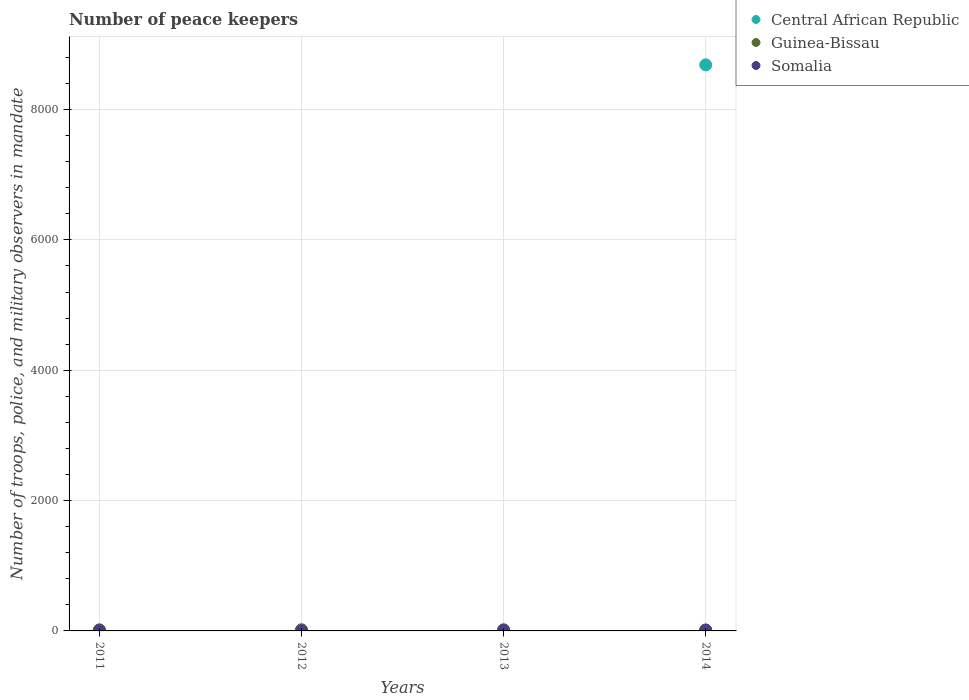Is the number of dotlines equal to the number of legend labels?
Your answer should be compact. Yes. Across all years, what is the minimum number of peace keepers in in Somalia?
Provide a succinct answer. 3. In which year was the number of peace keepers in in Somalia maximum?
Your response must be concise. 2014. In which year was the number of peace keepers in in Central African Republic minimum?
Your answer should be very brief. 2011. What is the total number of peace keepers in in Central African Republic in the graph?
Offer a very short reply. 8697. What is the difference between the number of peace keepers in in Guinea-Bissau in 2013 and that in 2014?
Offer a terse response. 4. What is the average number of peace keepers in in Guinea-Bissau per year?
Your answer should be compact. 16.75. In how many years, is the number of peace keepers in in Somalia greater than 5600?
Your response must be concise. 0. What is the ratio of the number of peace keepers in in Central African Republic in 2011 to that in 2012?
Your answer should be very brief. 1. Is the number of peace keepers in in Central African Republic in 2012 less than that in 2014?
Offer a very short reply. Yes. Is the difference between the number of peace keepers in in Somalia in 2011 and 2013 greater than the difference between the number of peace keepers in in Guinea-Bissau in 2011 and 2013?
Provide a succinct answer. No. What is the difference between the highest and the lowest number of peace keepers in in Central African Republic?
Provide a succinct answer. 8681. In how many years, is the number of peace keepers in in Guinea-Bissau greater than the average number of peace keepers in in Guinea-Bissau taken over all years?
Make the answer very short. 3. Is it the case that in every year, the sum of the number of peace keepers in in Guinea-Bissau and number of peace keepers in in Somalia  is greater than the number of peace keepers in in Central African Republic?
Provide a succinct answer. No. Is the number of peace keepers in in Guinea-Bissau strictly less than the number of peace keepers in in Central African Republic over the years?
Offer a very short reply. No. How many years are there in the graph?
Ensure brevity in your answer.  4. What is the difference between two consecutive major ticks on the Y-axis?
Your answer should be compact. 2000. Does the graph contain grids?
Provide a succinct answer. Yes. How many legend labels are there?
Make the answer very short. 3. How are the legend labels stacked?
Your response must be concise. Vertical. What is the title of the graph?
Offer a terse response. Number of peace keepers. What is the label or title of the Y-axis?
Offer a very short reply. Number of troops, police, and military observers in mandate. What is the Number of troops, police, and military observers in mandate in Central African Republic in 2011?
Offer a terse response. 4. What is the Number of troops, police, and military observers in mandate of Somalia in 2011?
Offer a very short reply. 6. What is the Number of troops, police, and military observers in mandate of Central African Republic in 2012?
Your answer should be very brief. 4. What is the Number of troops, police, and military observers in mandate in Guinea-Bissau in 2012?
Your answer should be very brief. 18. What is the Number of troops, police, and military observers in mandate of Somalia in 2012?
Ensure brevity in your answer.  3. What is the Number of troops, police, and military observers in mandate of Guinea-Bissau in 2013?
Give a very brief answer. 18. What is the Number of troops, police, and military observers in mandate of Central African Republic in 2014?
Offer a very short reply. 8685. What is the Number of troops, police, and military observers in mandate of Guinea-Bissau in 2014?
Your answer should be very brief. 14. What is the Number of troops, police, and military observers in mandate in Somalia in 2014?
Ensure brevity in your answer.  12. Across all years, what is the maximum Number of troops, police, and military observers in mandate in Central African Republic?
Offer a terse response. 8685. Across all years, what is the maximum Number of troops, police, and military observers in mandate of Guinea-Bissau?
Offer a very short reply. 18. Across all years, what is the maximum Number of troops, police, and military observers in mandate in Somalia?
Your answer should be compact. 12. Across all years, what is the minimum Number of troops, police, and military observers in mandate in Central African Republic?
Make the answer very short. 4. Across all years, what is the minimum Number of troops, police, and military observers in mandate in Somalia?
Provide a short and direct response. 3. What is the total Number of troops, police, and military observers in mandate in Central African Republic in the graph?
Provide a succinct answer. 8697. What is the total Number of troops, police, and military observers in mandate in Guinea-Bissau in the graph?
Make the answer very short. 67. What is the total Number of troops, police, and military observers in mandate of Somalia in the graph?
Give a very brief answer. 30. What is the difference between the Number of troops, police, and military observers in mandate of Central African Republic in 2011 and that in 2013?
Your answer should be very brief. 0. What is the difference between the Number of troops, police, and military observers in mandate in Central African Republic in 2011 and that in 2014?
Provide a succinct answer. -8681. What is the difference between the Number of troops, police, and military observers in mandate of Somalia in 2011 and that in 2014?
Your answer should be very brief. -6. What is the difference between the Number of troops, police, and military observers in mandate of Central African Republic in 2012 and that in 2013?
Ensure brevity in your answer.  0. What is the difference between the Number of troops, police, and military observers in mandate of Guinea-Bissau in 2012 and that in 2013?
Give a very brief answer. 0. What is the difference between the Number of troops, police, and military observers in mandate of Central African Republic in 2012 and that in 2014?
Offer a terse response. -8681. What is the difference between the Number of troops, police, and military observers in mandate in Guinea-Bissau in 2012 and that in 2014?
Your response must be concise. 4. What is the difference between the Number of troops, police, and military observers in mandate of Somalia in 2012 and that in 2014?
Offer a very short reply. -9. What is the difference between the Number of troops, police, and military observers in mandate of Central African Republic in 2013 and that in 2014?
Your answer should be compact. -8681. What is the difference between the Number of troops, police, and military observers in mandate in Guinea-Bissau in 2011 and the Number of troops, police, and military observers in mandate in Somalia in 2012?
Ensure brevity in your answer.  14. What is the difference between the Number of troops, police, and military observers in mandate in Central African Republic in 2011 and the Number of troops, police, and military observers in mandate in Guinea-Bissau in 2014?
Your response must be concise. -10. What is the difference between the Number of troops, police, and military observers in mandate of Guinea-Bissau in 2011 and the Number of troops, police, and military observers in mandate of Somalia in 2014?
Keep it short and to the point. 5. What is the difference between the Number of troops, police, and military observers in mandate in Central African Republic in 2012 and the Number of troops, police, and military observers in mandate in Guinea-Bissau in 2013?
Your answer should be compact. -14. What is the difference between the Number of troops, police, and military observers in mandate of Central African Republic in 2012 and the Number of troops, police, and military observers in mandate of Somalia in 2013?
Ensure brevity in your answer.  -5. What is the difference between the Number of troops, police, and military observers in mandate of Guinea-Bissau in 2012 and the Number of troops, police, and military observers in mandate of Somalia in 2013?
Provide a succinct answer. 9. What is the difference between the Number of troops, police, and military observers in mandate of Central African Republic in 2012 and the Number of troops, police, and military observers in mandate of Guinea-Bissau in 2014?
Ensure brevity in your answer.  -10. What is the difference between the Number of troops, police, and military observers in mandate of Central African Republic in 2012 and the Number of troops, police, and military observers in mandate of Somalia in 2014?
Your response must be concise. -8. What is the difference between the Number of troops, police, and military observers in mandate of Guinea-Bissau in 2012 and the Number of troops, police, and military observers in mandate of Somalia in 2014?
Provide a succinct answer. 6. What is the difference between the Number of troops, police, and military observers in mandate of Guinea-Bissau in 2013 and the Number of troops, police, and military observers in mandate of Somalia in 2014?
Give a very brief answer. 6. What is the average Number of troops, police, and military observers in mandate of Central African Republic per year?
Ensure brevity in your answer.  2174.25. What is the average Number of troops, police, and military observers in mandate in Guinea-Bissau per year?
Provide a short and direct response. 16.75. In the year 2011, what is the difference between the Number of troops, police, and military observers in mandate in Central African Republic and Number of troops, police, and military observers in mandate in Guinea-Bissau?
Your answer should be compact. -13. In the year 2011, what is the difference between the Number of troops, police, and military observers in mandate of Guinea-Bissau and Number of troops, police, and military observers in mandate of Somalia?
Offer a very short reply. 11. In the year 2013, what is the difference between the Number of troops, police, and military observers in mandate in Central African Republic and Number of troops, police, and military observers in mandate in Guinea-Bissau?
Provide a short and direct response. -14. In the year 2014, what is the difference between the Number of troops, police, and military observers in mandate in Central African Republic and Number of troops, police, and military observers in mandate in Guinea-Bissau?
Provide a succinct answer. 8671. In the year 2014, what is the difference between the Number of troops, police, and military observers in mandate of Central African Republic and Number of troops, police, and military observers in mandate of Somalia?
Your answer should be very brief. 8673. In the year 2014, what is the difference between the Number of troops, police, and military observers in mandate of Guinea-Bissau and Number of troops, police, and military observers in mandate of Somalia?
Provide a succinct answer. 2. What is the ratio of the Number of troops, police, and military observers in mandate in Central African Republic in 2011 to that in 2012?
Make the answer very short. 1. What is the ratio of the Number of troops, police, and military observers in mandate of Guinea-Bissau in 2011 to that in 2012?
Keep it short and to the point. 0.94. What is the ratio of the Number of troops, police, and military observers in mandate of Somalia in 2011 to that in 2012?
Offer a terse response. 2. What is the ratio of the Number of troops, police, and military observers in mandate in Central African Republic in 2011 to that in 2013?
Make the answer very short. 1. What is the ratio of the Number of troops, police, and military observers in mandate in Somalia in 2011 to that in 2013?
Your answer should be compact. 0.67. What is the ratio of the Number of troops, police, and military observers in mandate of Guinea-Bissau in 2011 to that in 2014?
Provide a succinct answer. 1.21. What is the ratio of the Number of troops, police, and military observers in mandate in Somalia in 2011 to that in 2014?
Your answer should be very brief. 0.5. What is the ratio of the Number of troops, police, and military observers in mandate in Central African Republic in 2012 to that in 2013?
Offer a terse response. 1. What is the ratio of the Number of troops, police, and military observers in mandate of Somalia in 2012 to that in 2013?
Provide a short and direct response. 0.33. What is the ratio of the Number of troops, police, and military observers in mandate of Central African Republic in 2012 to that in 2014?
Keep it short and to the point. 0. What is the ratio of the Number of troops, police, and military observers in mandate of Guinea-Bissau in 2012 to that in 2014?
Your response must be concise. 1.29. What is the ratio of the Number of troops, police, and military observers in mandate in Guinea-Bissau in 2013 to that in 2014?
Offer a very short reply. 1.29. What is the ratio of the Number of troops, police, and military observers in mandate of Somalia in 2013 to that in 2014?
Provide a succinct answer. 0.75. What is the difference between the highest and the second highest Number of troops, police, and military observers in mandate in Central African Republic?
Make the answer very short. 8681. What is the difference between the highest and the second highest Number of troops, police, and military observers in mandate of Guinea-Bissau?
Keep it short and to the point. 0. What is the difference between the highest and the second highest Number of troops, police, and military observers in mandate in Somalia?
Make the answer very short. 3. What is the difference between the highest and the lowest Number of troops, police, and military observers in mandate of Central African Republic?
Make the answer very short. 8681. 